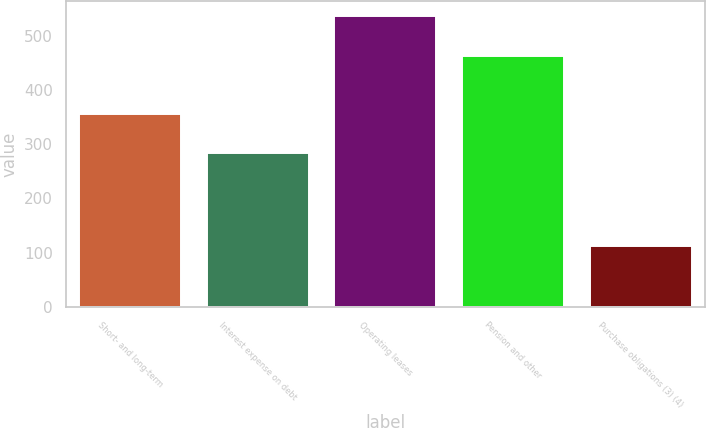Convert chart to OTSL. <chart><loc_0><loc_0><loc_500><loc_500><bar_chart><fcel>Short- and long-term<fcel>Interest expense on debt<fcel>Operating leases<fcel>Pension and other<fcel>Purchase obligations (3) (4)<nl><fcel>356<fcel>283<fcel>537<fcel>463<fcel>113<nl></chart> 